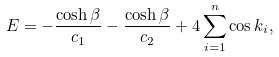Convert formula to latex. <formula><loc_0><loc_0><loc_500><loc_500>E = - \frac { \cosh \beta } { c _ { 1 } } - \frac { \cosh \beta } { c _ { 2 } } + 4 \sum ^ { n } _ { i = 1 } \cos k _ { i } ,</formula> 